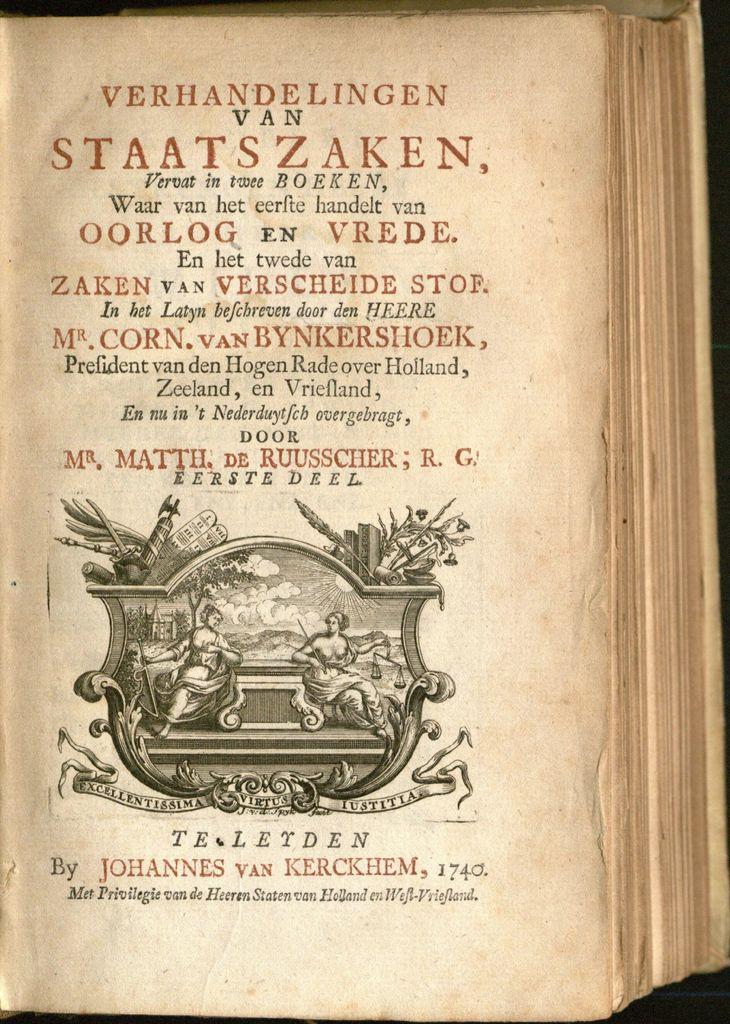What is the book theyre reading?
Your answer should be compact. Verhandelingen van staatszaken. Who wrote this book?
Your response must be concise. Johannes van kerckhem. 